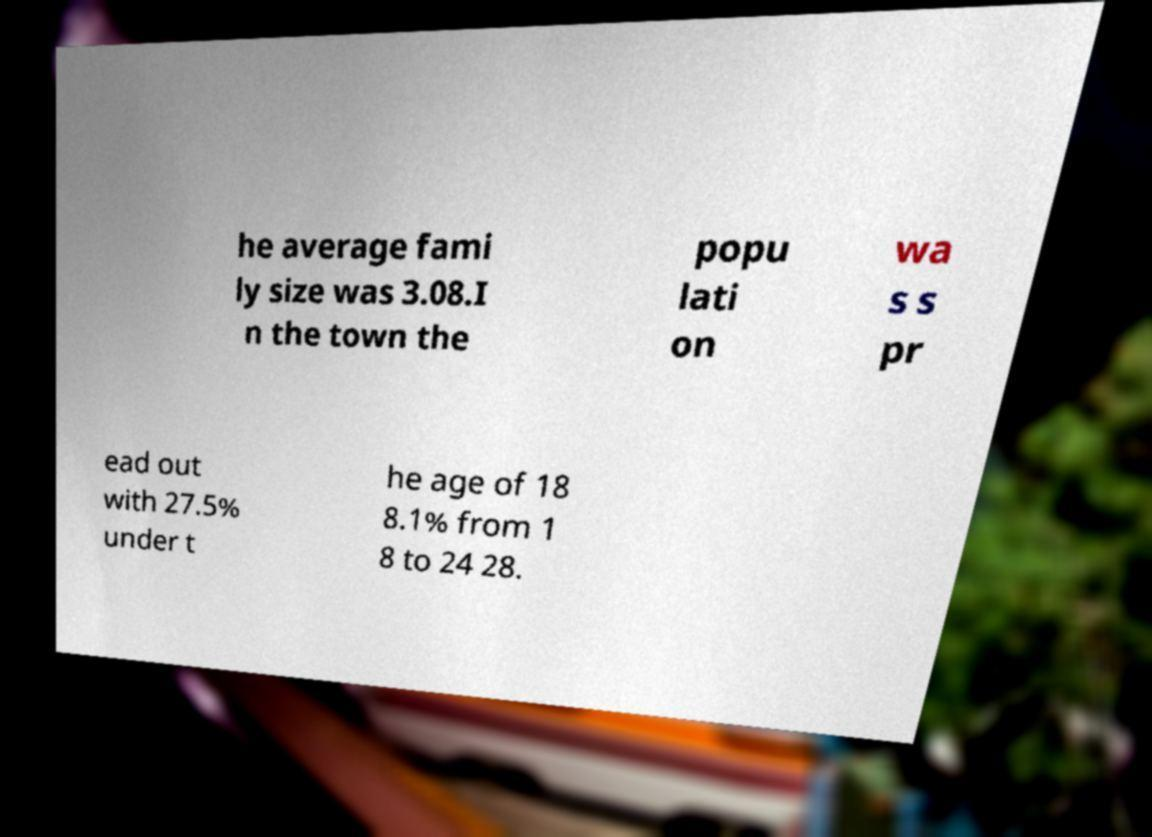I need the written content from this picture converted into text. Can you do that? he average fami ly size was 3.08.I n the town the popu lati on wa s s pr ead out with 27.5% under t he age of 18 8.1% from 1 8 to 24 28. 